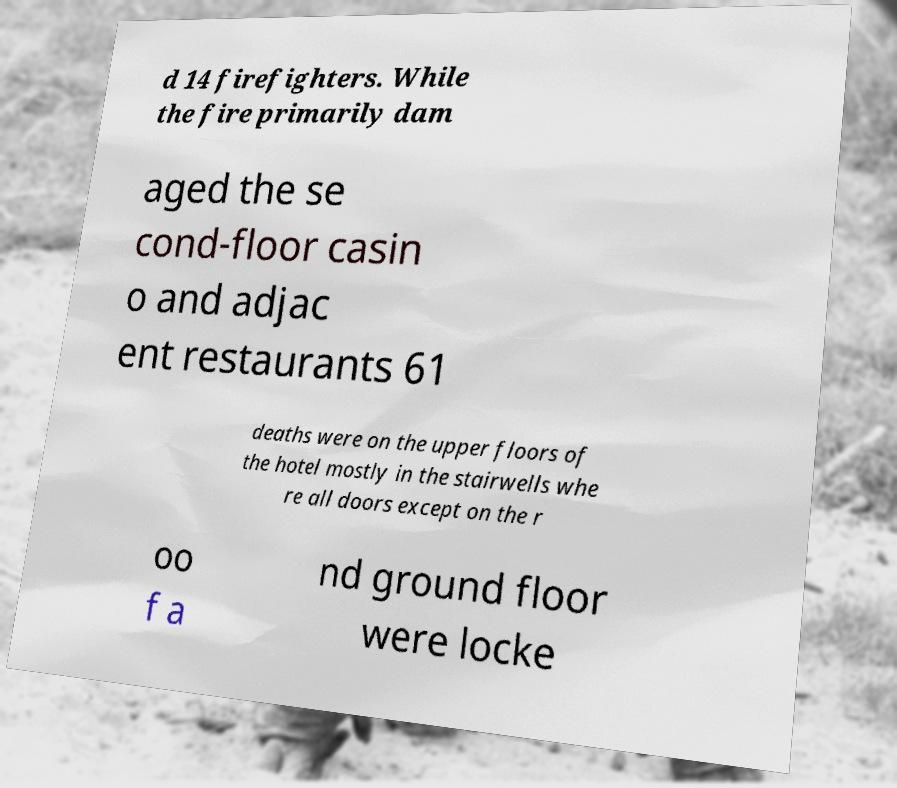I need the written content from this picture converted into text. Can you do that? d 14 firefighters. While the fire primarily dam aged the se cond-floor casin o and adjac ent restaurants 61 deaths were on the upper floors of the hotel mostly in the stairwells whe re all doors except on the r oo f a nd ground floor were locke 